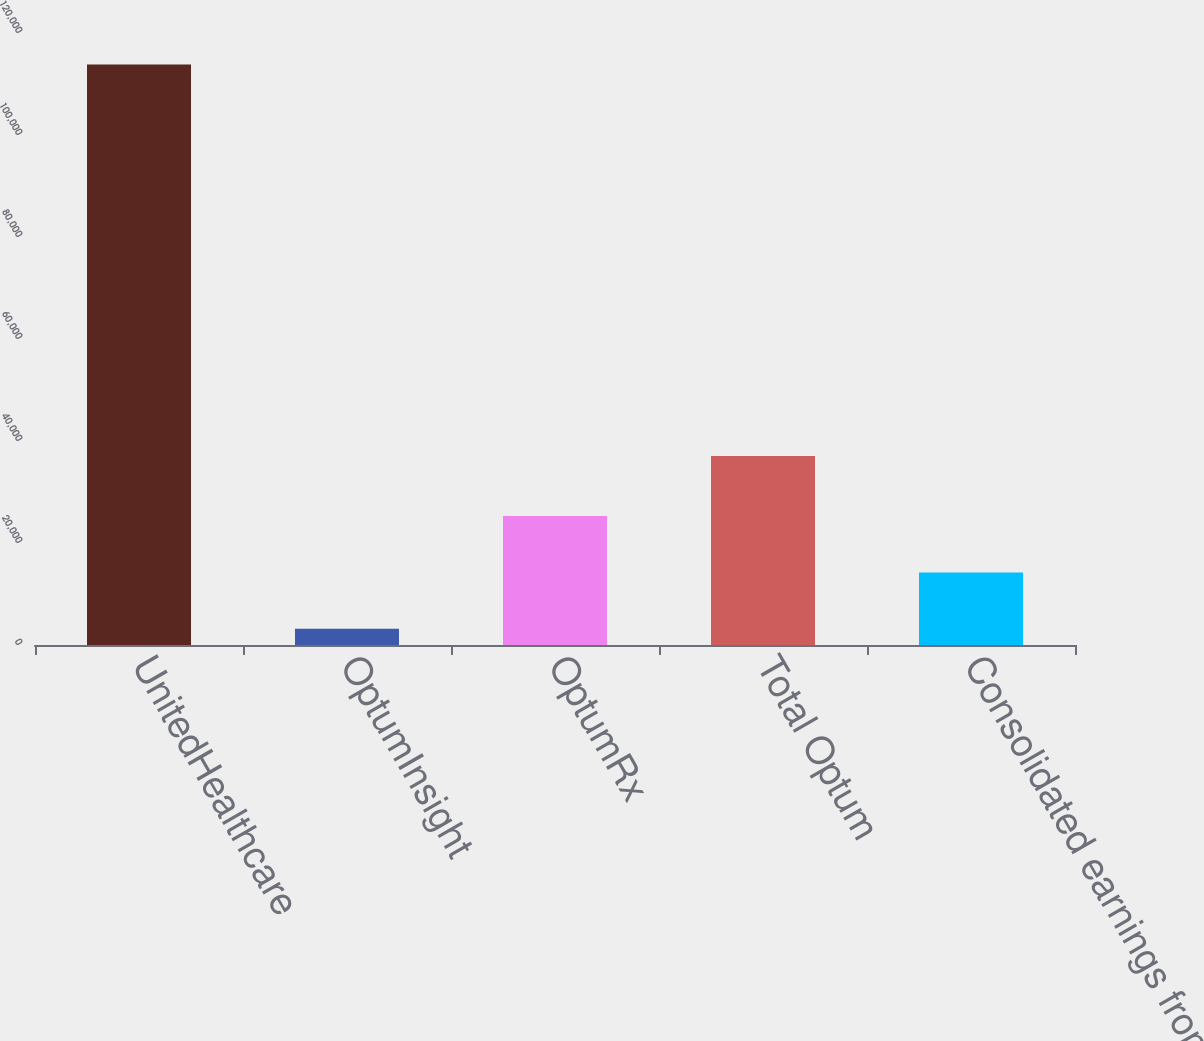<chart> <loc_0><loc_0><loc_500><loc_500><bar_chart><fcel>UnitedHealthcare<fcel>OptumInsight<fcel>OptumRx<fcel>Total Optum<fcel>Consolidated earnings from<nl><fcel>113829<fcel>3174<fcel>25305<fcel>37035<fcel>14239.5<nl></chart> 